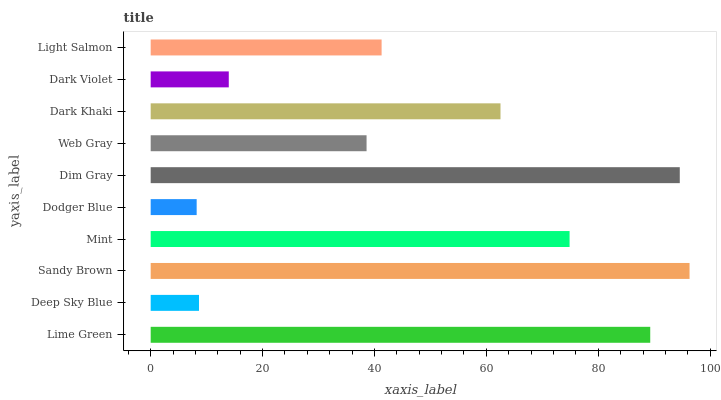Is Dodger Blue the minimum?
Answer yes or no. Yes. Is Sandy Brown the maximum?
Answer yes or no. Yes. Is Deep Sky Blue the minimum?
Answer yes or no. No. Is Deep Sky Blue the maximum?
Answer yes or no. No. Is Lime Green greater than Deep Sky Blue?
Answer yes or no. Yes. Is Deep Sky Blue less than Lime Green?
Answer yes or no. Yes. Is Deep Sky Blue greater than Lime Green?
Answer yes or no. No. Is Lime Green less than Deep Sky Blue?
Answer yes or no. No. Is Dark Khaki the high median?
Answer yes or no. Yes. Is Light Salmon the low median?
Answer yes or no. Yes. Is Light Salmon the high median?
Answer yes or no. No. Is Deep Sky Blue the low median?
Answer yes or no. No. 